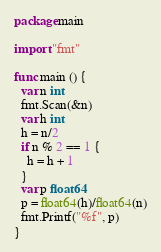Convert code to text. <code><loc_0><loc_0><loc_500><loc_500><_Go_>package main
 
import "fmt"
 
func main () {
  var n int
  fmt.Scan(&n)
  var h int
  h = n/2
  if n % 2 == 1 {
    h = h + 1
  }
  var p float64
  p = float64(h)/float64(n)
  fmt.Printf("%f", p)
} </code> 